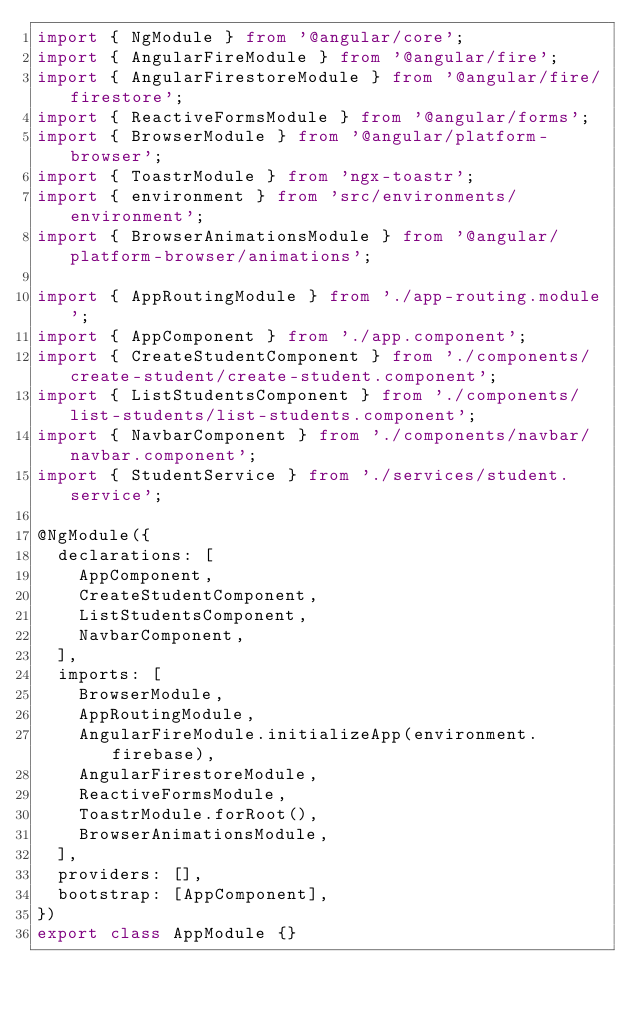Convert code to text. <code><loc_0><loc_0><loc_500><loc_500><_TypeScript_>import { NgModule } from '@angular/core';
import { AngularFireModule } from '@angular/fire';
import { AngularFirestoreModule } from '@angular/fire/firestore';
import { ReactiveFormsModule } from '@angular/forms';
import { BrowserModule } from '@angular/platform-browser';
import { ToastrModule } from 'ngx-toastr';
import { environment } from 'src/environments/environment';
import { BrowserAnimationsModule } from '@angular/platform-browser/animations';

import { AppRoutingModule } from './app-routing.module';
import { AppComponent } from './app.component';
import { CreateStudentComponent } from './components/create-student/create-student.component';
import { ListStudentsComponent } from './components/list-students/list-students.component';
import { NavbarComponent } from './components/navbar/navbar.component';
import { StudentService } from './services/student.service';

@NgModule({
  declarations: [
    AppComponent,
    CreateStudentComponent,
    ListStudentsComponent,
    NavbarComponent,
  ],
  imports: [
    BrowserModule,
    AppRoutingModule,
    AngularFireModule.initializeApp(environment.firebase),
    AngularFirestoreModule,
    ReactiveFormsModule,
    ToastrModule.forRoot(),
    BrowserAnimationsModule,
  ],
  providers: [],
  bootstrap: [AppComponent],
})
export class AppModule {}
</code> 